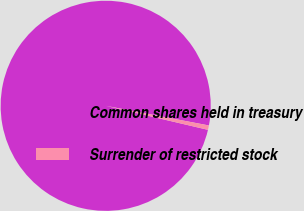<chart> <loc_0><loc_0><loc_500><loc_500><pie_chart><fcel>Common shares held in treasury<fcel>Surrender of restricted stock<nl><fcel>99.32%<fcel>0.68%<nl></chart> 